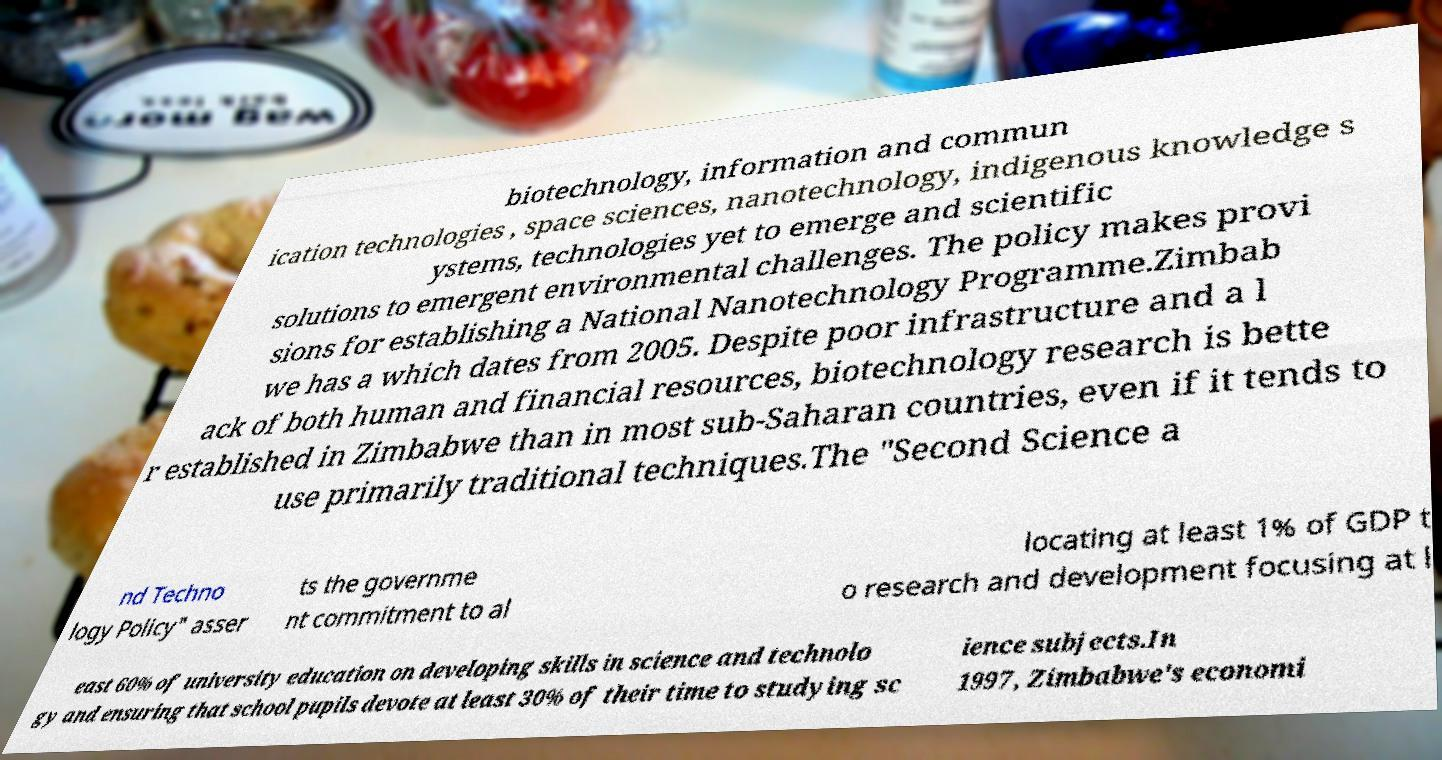Could you extract and type out the text from this image? biotechnology, information and commun ication technologies , space sciences, nanotechnology, indigenous knowledge s ystems, technologies yet to emerge and scientific solutions to emergent environmental challenges. The policy makes provi sions for establishing a National Nanotechnology Programme.Zimbab we has a which dates from 2005. Despite poor infrastructure and a l ack of both human and financial resources, biotechnology research is bette r established in Zimbabwe than in most sub-Saharan countries, even if it tends to use primarily traditional techniques.The "Second Science a nd Techno logy Policy" asser ts the governme nt commitment to al locating at least 1% of GDP t o research and development focusing at l east 60% of university education on developing skills in science and technolo gy and ensuring that school pupils devote at least 30% of their time to studying sc ience subjects.In 1997, Zimbabwe's economi 